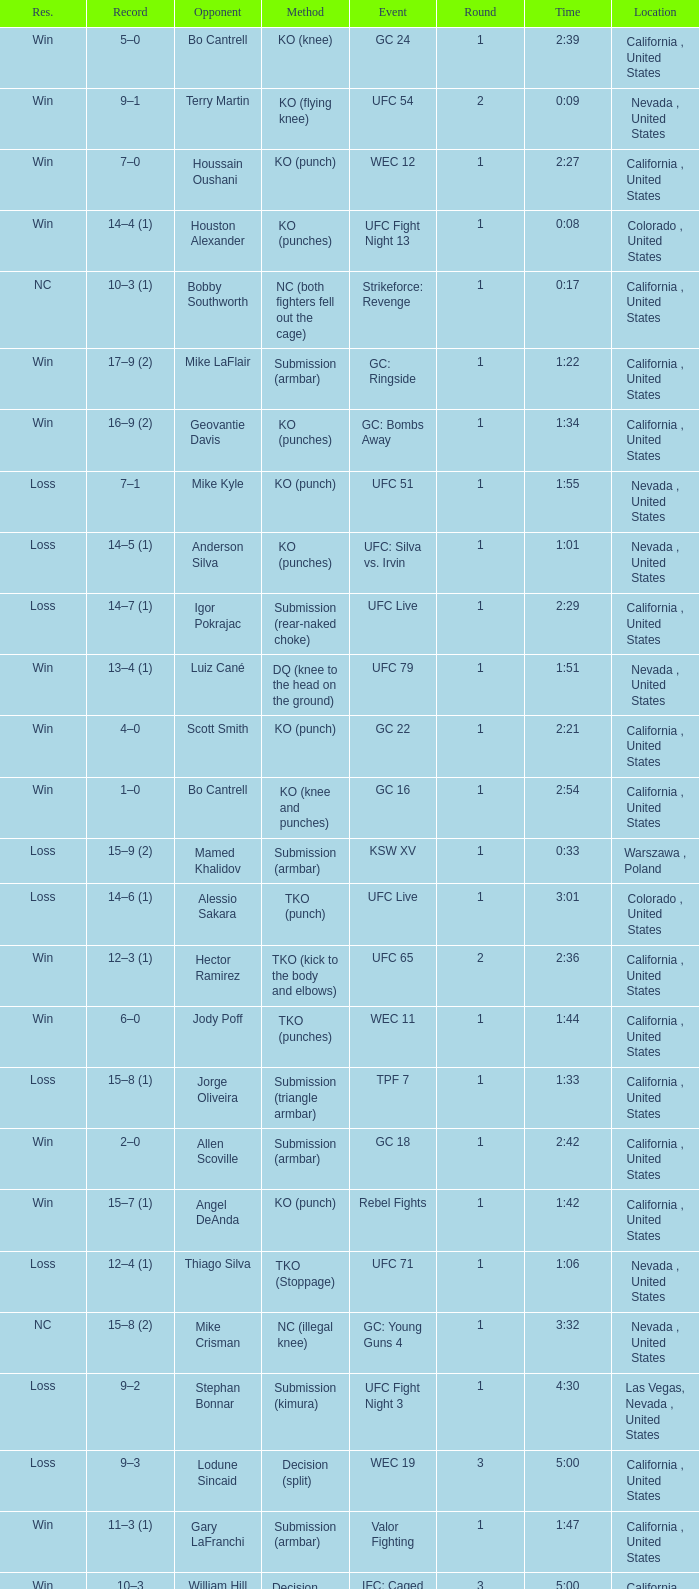Could you parse the entire table? {'header': ['Res.', 'Record', 'Opponent', 'Method', 'Event', 'Round', 'Time', 'Location'], 'rows': [['Win', '5–0', 'Bo Cantrell', 'KO (knee)', 'GC 24', '1', '2:39', 'California , United States'], ['Win', '9–1', 'Terry Martin', 'KO (flying knee)', 'UFC 54', '2', '0:09', 'Nevada , United States'], ['Win', '7–0', 'Houssain Oushani', 'KO (punch)', 'WEC 12', '1', '2:27', 'California , United States'], ['Win', '14–4 (1)', 'Houston Alexander', 'KO (punches)', 'UFC Fight Night 13', '1', '0:08', 'Colorado , United States'], ['NC', '10–3 (1)', 'Bobby Southworth', 'NC (both fighters fell out the cage)', 'Strikeforce: Revenge', '1', '0:17', 'California , United States'], ['Win', '17–9 (2)', 'Mike LaFlair', 'Submission (armbar)', 'GC: Ringside', '1', '1:22', 'California , United States'], ['Win', '16–9 (2)', 'Geovantie Davis', 'KO (punches)', 'GC: Bombs Away', '1', '1:34', 'California , United States'], ['Loss', '7–1', 'Mike Kyle', 'KO (punch)', 'UFC 51', '1', '1:55', 'Nevada , United States'], ['Loss', '14–5 (1)', 'Anderson Silva', 'KO (punches)', 'UFC: Silva vs. Irvin', '1', '1:01', 'Nevada , United States'], ['Loss', '14–7 (1)', 'Igor Pokrajac', 'Submission (rear-naked choke)', 'UFC Live', '1', '2:29', 'California , United States'], ['Win', '13–4 (1)', 'Luiz Cané', 'DQ (knee to the head on the ground)', 'UFC 79', '1', '1:51', 'Nevada , United States'], ['Win', '4–0', 'Scott Smith', 'KO (punch)', 'GC 22', '1', '2:21', 'California , United States'], ['Win', '1–0', 'Bo Cantrell', 'KO (knee and punches)', 'GC 16', '1', '2:54', 'California , United States'], ['Loss', '15–9 (2)', 'Mamed Khalidov', 'Submission (armbar)', 'KSW XV', '1', '0:33', 'Warszawa , Poland'], ['Loss', '14–6 (1)', 'Alessio Sakara', 'TKO (punch)', 'UFC Live', '1', '3:01', 'Colorado , United States'], ['Win', '12–3 (1)', 'Hector Ramirez', 'TKO (kick to the body and elbows)', 'UFC 65', '2', '2:36', 'California , United States'], ['Win', '6–0', 'Jody Poff', 'TKO (punches)', 'WEC 11', '1', '1:44', 'California , United States'], ['Loss', '15–8 (1)', 'Jorge Oliveira', 'Submission (triangle armbar)', 'TPF 7', '1', '1:33', 'California , United States'], ['Win', '2–0', 'Allen Scoville', 'Submission (armbar)', 'GC 18', '1', '2:42', 'California , United States'], ['Win', '15–7 (1)', 'Angel DeAnda', 'KO (punch)', 'Rebel Fights', '1', '1:42', 'California , United States'], ['Loss', '12–4 (1)', 'Thiago Silva', 'TKO (Stoppage)', 'UFC 71', '1', '1:06', 'Nevada , United States'], ['NC', '15–8 (2)', 'Mike Crisman', 'NC (illegal knee)', 'GC: Young Guns 4', '1', '3:32', 'Nevada , United States'], ['Loss', '9–2', 'Stephan Bonnar', 'Submission (kimura)', 'UFC Fight Night 3', '1', '4:30', 'Las Vegas, Nevada , United States'], ['Loss', '9–3', 'Lodune Sincaid', 'Decision (split)', 'WEC 19', '3', '5:00', 'California , United States'], ['Win', '11–3 (1)', 'Gary LaFranchi', 'Submission (armbar)', 'Valor Fighting', '1', '1:47', 'California , United States'], ['Win', '10–3', 'William Hill', 'Decision (unanimous)', 'IFC: Caged', '3', '5:00', 'California , United States'], ['Win', '3–0', 'Pete Werve', 'TKO (doctor stoppage)', 'GC 20', '1', '5:00', 'California , United States'], ['Win', '8–1', 'Doug Marshall', 'KO (knee)', 'WEC 15', '2', '0:45', 'California , United States'], ['Loss', '17–10 (2)', 'Scott Rosa', 'TKO (knees and punches)', 'GC: Star Wars', '2', '1:35', 'California , United States']]} What is the method where there is a loss with time 5:00? Decision (split). 